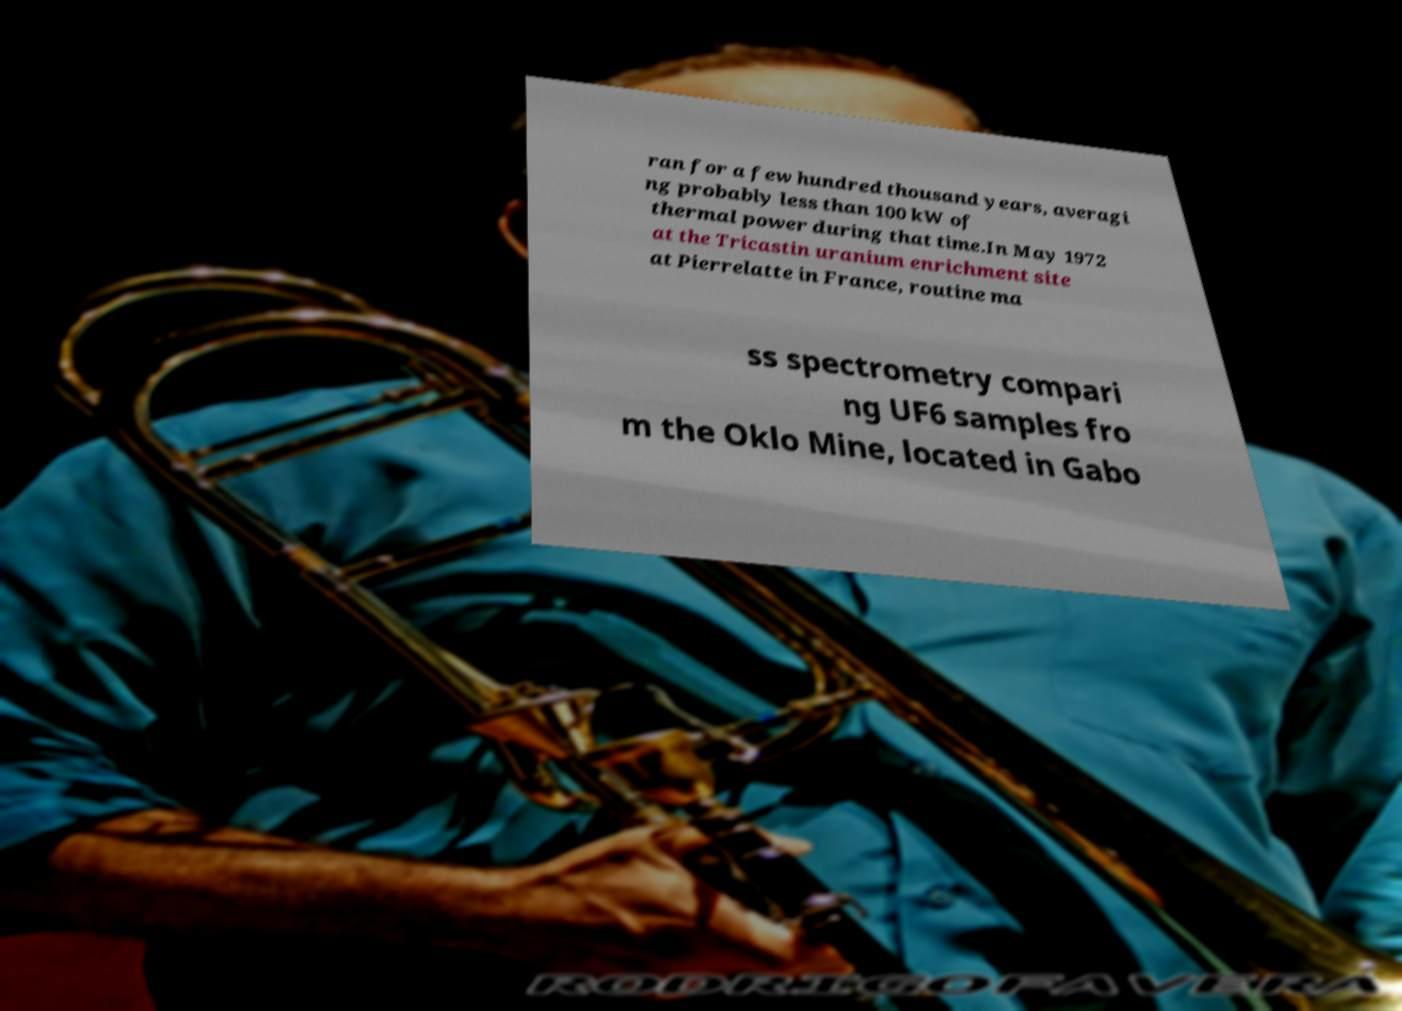For documentation purposes, I need the text within this image transcribed. Could you provide that? ran for a few hundred thousand years, averagi ng probably less than 100 kW of thermal power during that time.In May 1972 at the Tricastin uranium enrichment site at Pierrelatte in France, routine ma ss spectrometry compari ng UF6 samples fro m the Oklo Mine, located in Gabo 